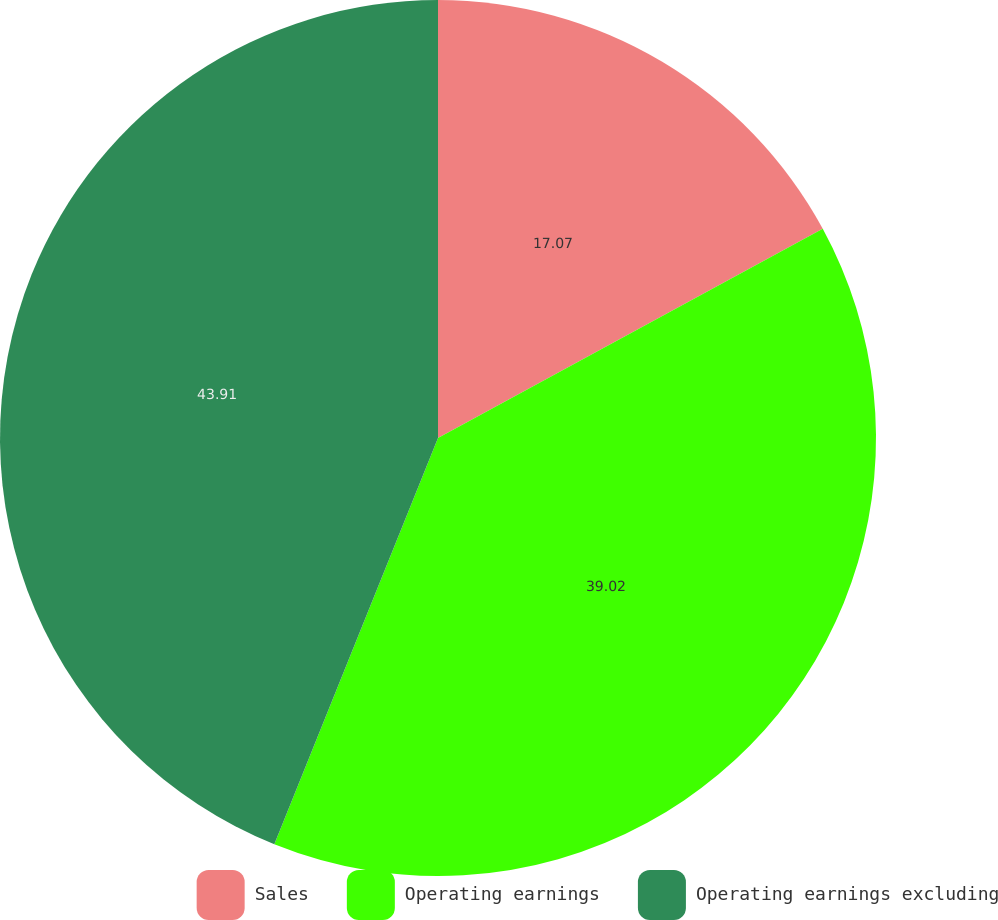Convert chart to OTSL. <chart><loc_0><loc_0><loc_500><loc_500><pie_chart><fcel>Sales<fcel>Operating earnings<fcel>Operating earnings excluding<nl><fcel>17.07%<fcel>39.02%<fcel>43.9%<nl></chart> 